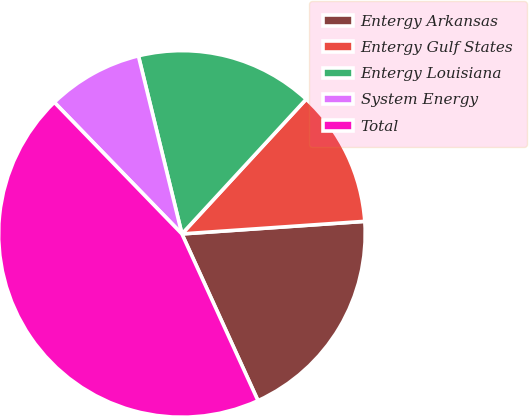<chart> <loc_0><loc_0><loc_500><loc_500><pie_chart><fcel>Entergy Arkansas<fcel>Entergy Gulf States<fcel>Entergy Louisiana<fcel>System Energy<fcel>Total<nl><fcel>19.28%<fcel>12.05%<fcel>15.67%<fcel>8.44%<fcel>44.56%<nl></chart> 